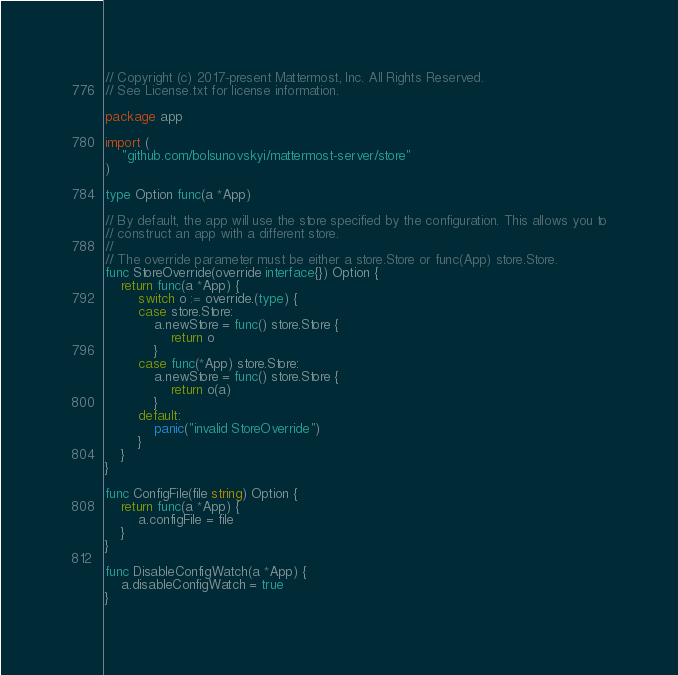<code> <loc_0><loc_0><loc_500><loc_500><_Go_>// Copyright (c) 2017-present Mattermost, Inc. All Rights Reserved.
// See License.txt for license information.

package app

import (
	"github.com/bolsunovskyi/mattermost-server/store"
)

type Option func(a *App)

// By default, the app will use the store specified by the configuration. This allows you to
// construct an app with a different store.
//
// The override parameter must be either a store.Store or func(App) store.Store.
func StoreOverride(override interface{}) Option {
	return func(a *App) {
		switch o := override.(type) {
		case store.Store:
			a.newStore = func() store.Store {
				return o
			}
		case func(*App) store.Store:
			a.newStore = func() store.Store {
				return o(a)
			}
		default:
			panic("invalid StoreOverride")
		}
	}
}

func ConfigFile(file string) Option {
	return func(a *App) {
		a.configFile = file
	}
}

func DisableConfigWatch(a *App) {
	a.disableConfigWatch = true
}
</code> 